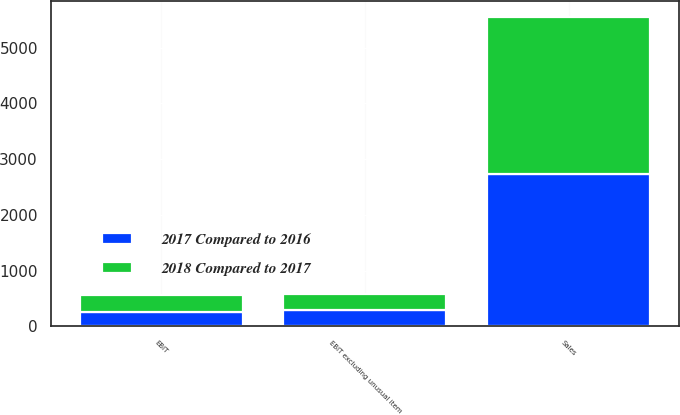Convert chart. <chart><loc_0><loc_0><loc_500><loc_500><stacked_bar_chart><ecel><fcel>Sales<fcel>EBIT<fcel>EBIT excluding unusual item<nl><fcel>2018 Compared to 2017<fcel>2831<fcel>308<fcel>278<nl><fcel>2017 Compared to 2016<fcel>2728<fcel>255<fcel>299<nl></chart> 